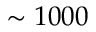Convert formula to latex. <formula><loc_0><loc_0><loc_500><loc_500>\sim 1 0 0 0</formula> 